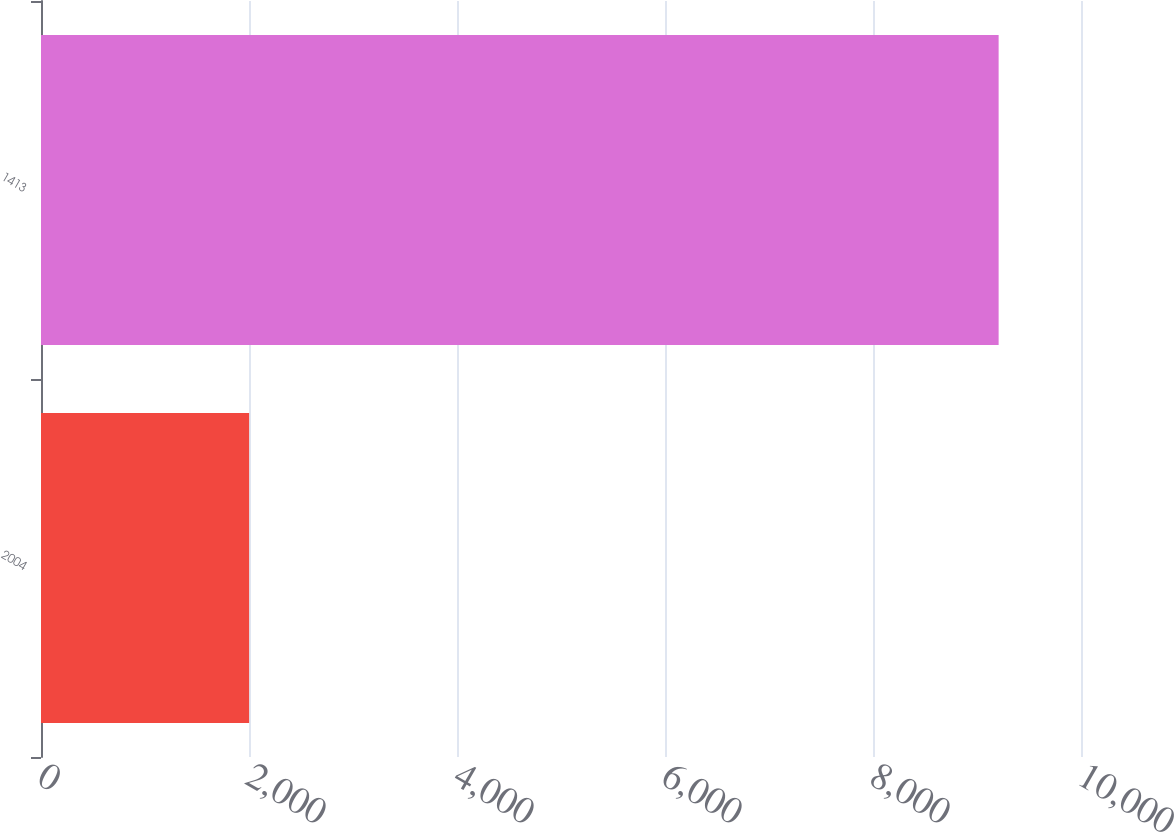<chart> <loc_0><loc_0><loc_500><loc_500><bar_chart><fcel>2004<fcel>1413<nl><fcel>2001<fcel>9208<nl></chart> 